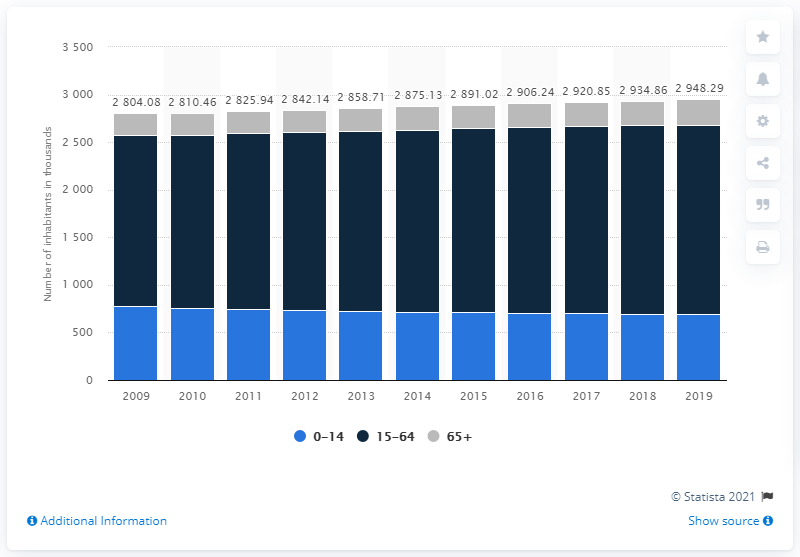Give some essential details in this illustration. From 2009 to present, Jamaica's population has shown a steady increase. 